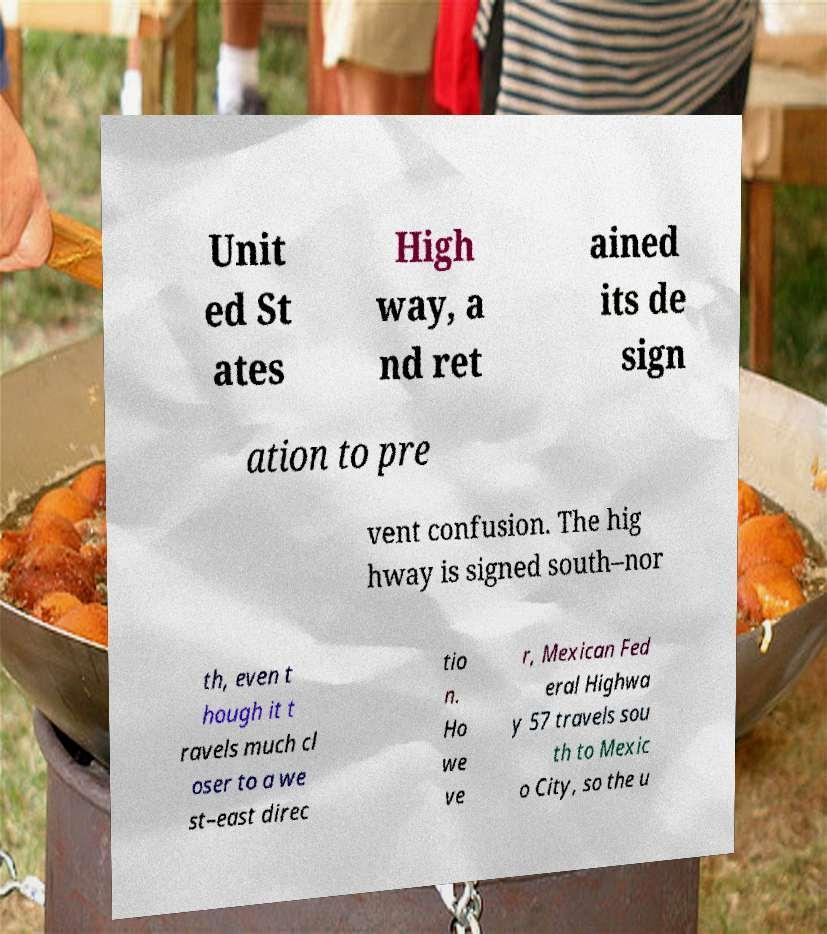Can you read and provide the text displayed in the image?This photo seems to have some interesting text. Can you extract and type it out for me? Unit ed St ates High way, a nd ret ained its de sign ation to pre vent confusion. The hig hway is signed south–nor th, even t hough it t ravels much cl oser to a we st–east direc tio n. Ho we ve r, Mexican Fed eral Highwa y 57 travels sou th to Mexic o City, so the u 